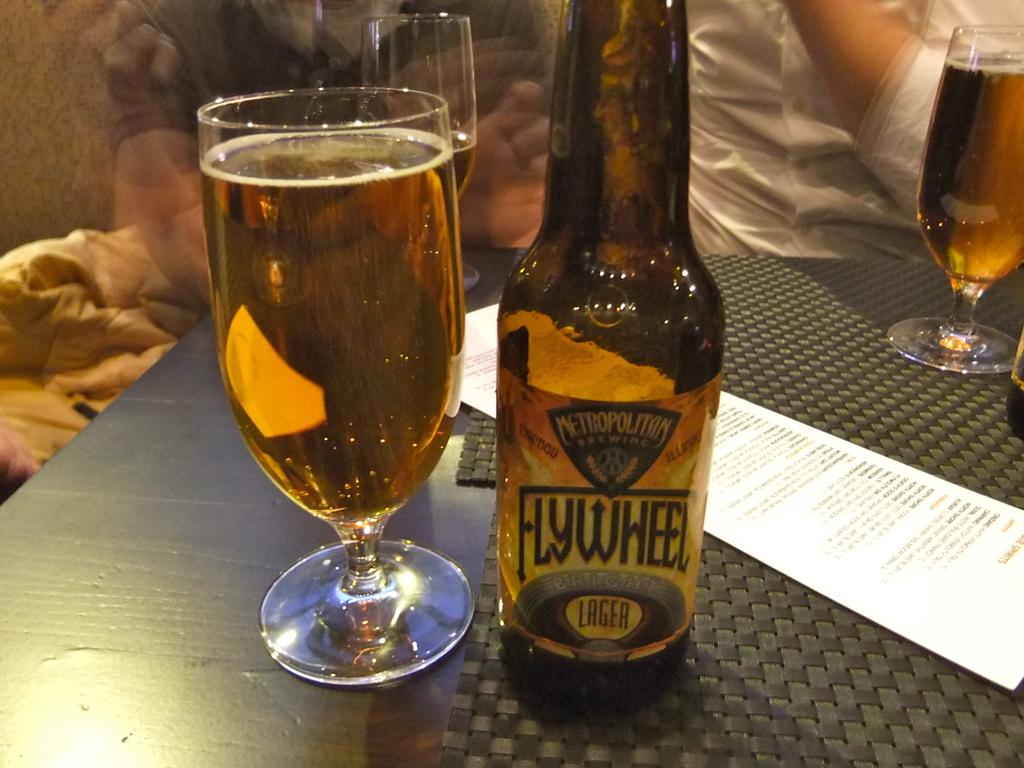What kind of beer is this?
Make the answer very short. Lager. 